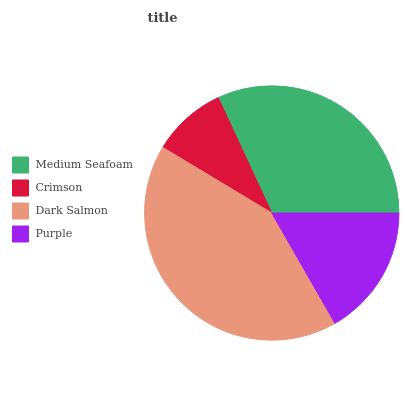Is Crimson the minimum?
Answer yes or no. Yes. Is Dark Salmon the maximum?
Answer yes or no. Yes. Is Dark Salmon the minimum?
Answer yes or no. No. Is Crimson the maximum?
Answer yes or no. No. Is Dark Salmon greater than Crimson?
Answer yes or no. Yes. Is Crimson less than Dark Salmon?
Answer yes or no. Yes. Is Crimson greater than Dark Salmon?
Answer yes or no. No. Is Dark Salmon less than Crimson?
Answer yes or no. No. Is Medium Seafoam the high median?
Answer yes or no. Yes. Is Purple the low median?
Answer yes or no. Yes. Is Dark Salmon the high median?
Answer yes or no. No. Is Medium Seafoam the low median?
Answer yes or no. No. 